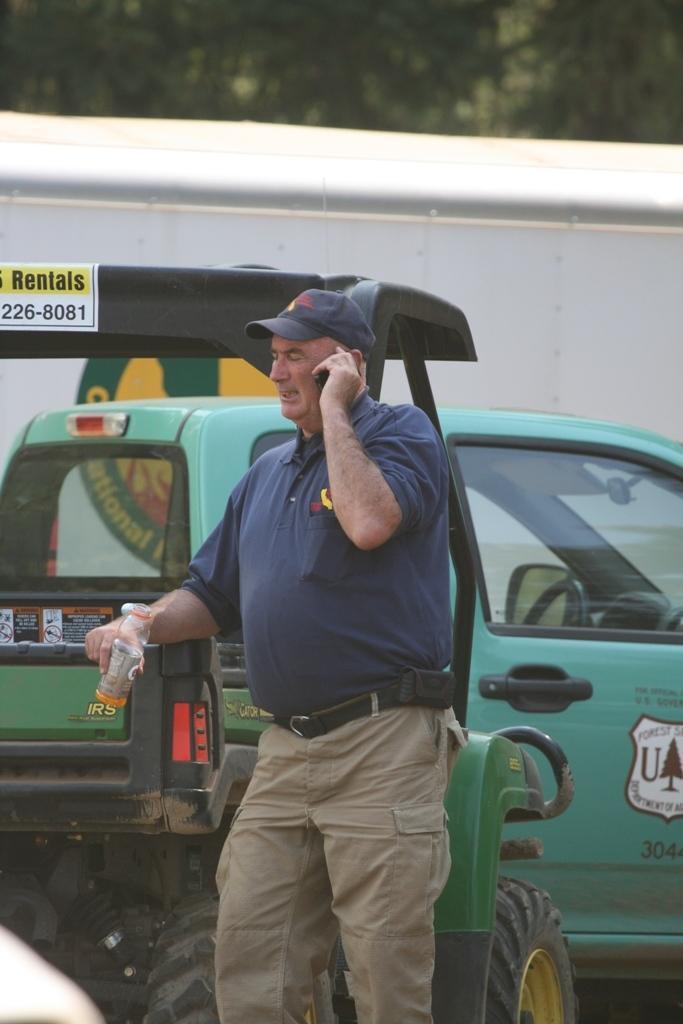In one or two sentences, can you explain what this image depicts? In this picture we can see a man wore a cap and holding a bottle with his hand and standing, vehicles and in the background we can see trees. 